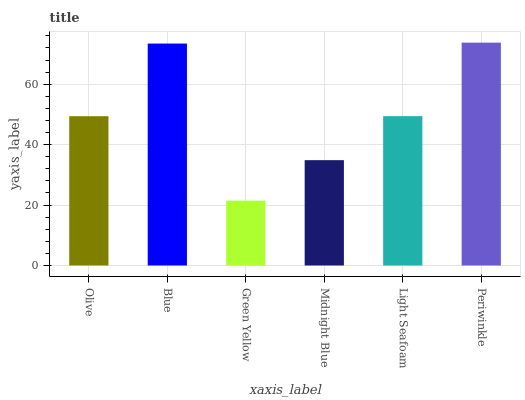Is Green Yellow the minimum?
Answer yes or no. Yes. Is Periwinkle the maximum?
Answer yes or no. Yes. Is Blue the minimum?
Answer yes or no. No. Is Blue the maximum?
Answer yes or no. No. Is Blue greater than Olive?
Answer yes or no. Yes. Is Olive less than Blue?
Answer yes or no. Yes. Is Olive greater than Blue?
Answer yes or no. No. Is Blue less than Olive?
Answer yes or no. No. Is Light Seafoam the high median?
Answer yes or no. Yes. Is Olive the low median?
Answer yes or no. Yes. Is Olive the high median?
Answer yes or no. No. Is Blue the low median?
Answer yes or no. No. 